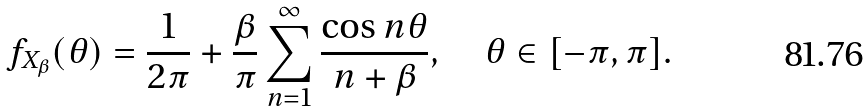<formula> <loc_0><loc_0><loc_500><loc_500>f _ { X _ { \beta } } ( \theta ) = \frac { 1 } { 2 \pi } + \frac { \beta } { \pi } \sum _ { n = 1 } ^ { \infty } \frac { \cos n \theta } { n + \beta } , \quad \theta \in [ - \pi , \pi ] .</formula> 